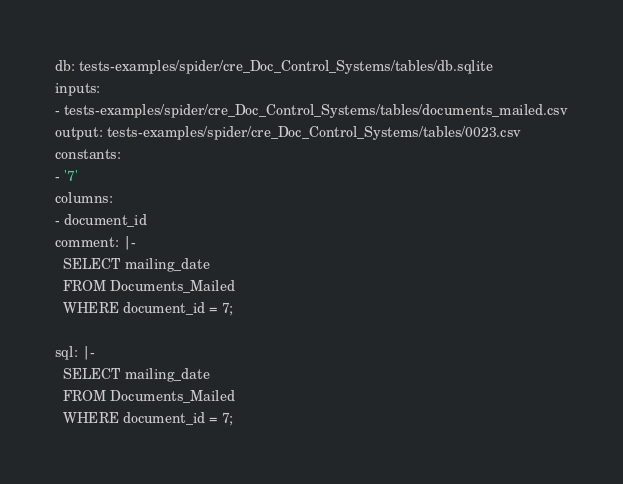Convert code to text. <code><loc_0><loc_0><loc_500><loc_500><_YAML_>db: tests-examples/spider/cre_Doc_Control_Systems/tables/db.sqlite
inputs:
- tests-examples/spider/cre_Doc_Control_Systems/tables/documents_mailed.csv
output: tests-examples/spider/cre_Doc_Control_Systems/tables/0023.csv
constants:
- '7'
columns:
- document_id
comment: |-
  SELECT mailing_date
  FROM Documents_Mailed
  WHERE document_id = 7;

sql: |-
  SELECT mailing_date
  FROM Documents_Mailed
  WHERE document_id = 7;</code> 